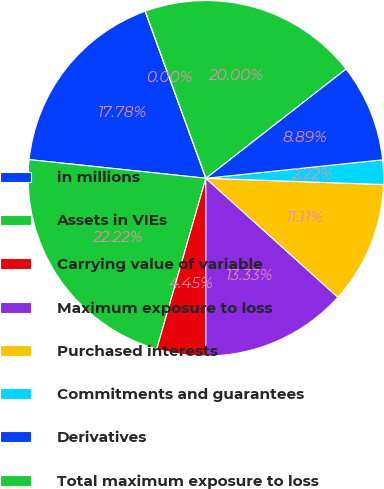Convert chart to OTSL. <chart><loc_0><loc_0><loc_500><loc_500><pie_chart><fcel>in millions<fcel>Assets in VIEs<fcel>Carrying value of variable<fcel>Maximum exposure to loss<fcel>Purchased interests<fcel>Commitments and guarantees<fcel>Derivatives<fcel>Total maximum exposure to loss<fcel>Retained interests<nl><fcel>17.78%<fcel>22.22%<fcel>4.45%<fcel>13.33%<fcel>11.11%<fcel>2.22%<fcel>8.89%<fcel>20.0%<fcel>0.0%<nl></chart> 